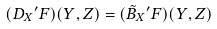<formula> <loc_0><loc_0><loc_500><loc_500>( D _ { X } { ^ { \prime } F } ) ( Y , Z ) = ( \tilde { B } _ { X } { ^ { \prime } F } ) ( Y , Z )</formula> 